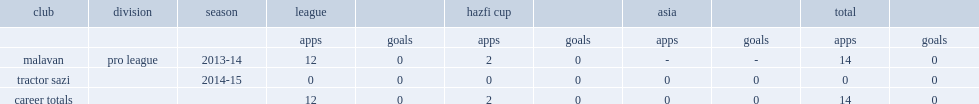Which season did mohammad pour rahmatollah make his debut for malavan in pro league? 2013-14. 